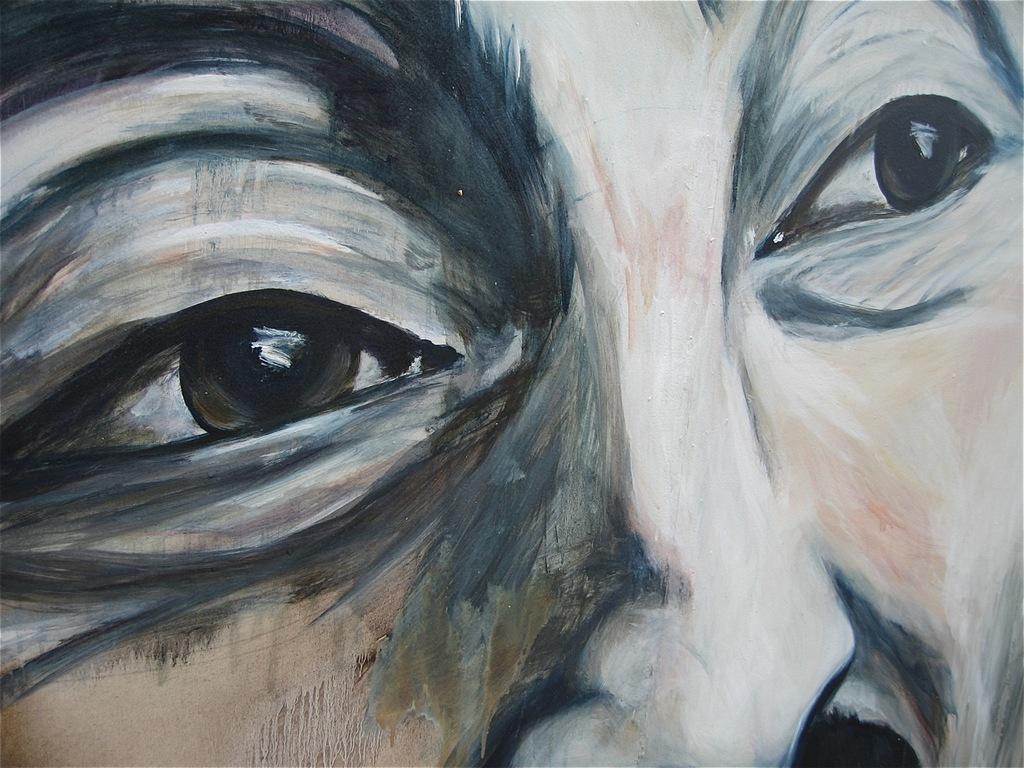Describe this image in one or two sentences. In the picture I can see a painting of a person´s face where I can eyes and nose. 